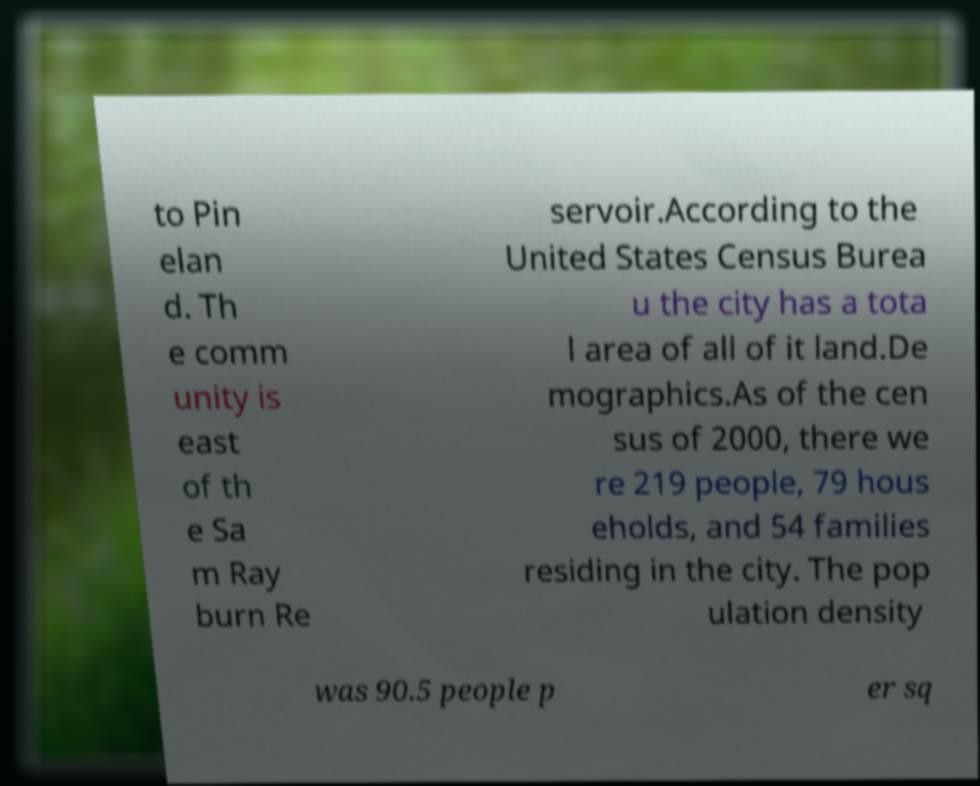Please identify and transcribe the text found in this image. to Pin elan d. Th e comm unity is east of th e Sa m Ray burn Re servoir.According to the United States Census Burea u the city has a tota l area of all of it land.De mographics.As of the cen sus of 2000, there we re 219 people, 79 hous eholds, and 54 families residing in the city. The pop ulation density was 90.5 people p er sq 